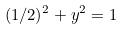Convert formula to latex. <formula><loc_0><loc_0><loc_500><loc_500>( 1 / 2 ) ^ { 2 } + y ^ { 2 } = 1</formula> 